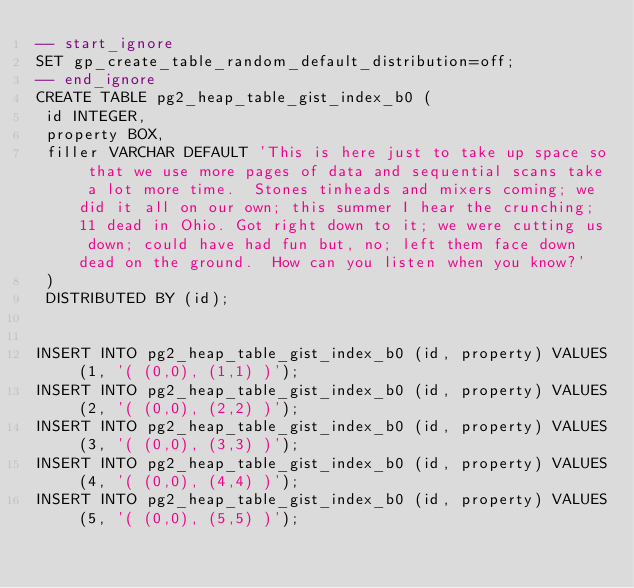<code> <loc_0><loc_0><loc_500><loc_500><_SQL_>-- start_ignore
SET gp_create_table_random_default_distribution=off;
-- end_ignore
CREATE TABLE pg2_heap_table_gist_index_b0 (
 id INTEGER,
 property BOX,
 filler VARCHAR DEFAULT 'This is here just to take up space so that we use more pages of data and sequential scans take a lot more time.  Stones tinheads and mixers coming; we did it all on our own; this summer I hear the crunching; 11 dead in Ohio. Got right down to it; we were cutting us down; could have had fun but, no; left them face down dead on the ground.  How can you listen when you know?'
 )
 DISTRIBUTED BY (id);


INSERT INTO pg2_heap_table_gist_index_b0 (id, property) VALUES (1, '( (0,0), (1,1) )');
INSERT INTO pg2_heap_table_gist_index_b0 (id, property) VALUES (2, '( (0,0), (2,2) )');
INSERT INTO pg2_heap_table_gist_index_b0 (id, property) VALUES (3, '( (0,0), (3,3) )');
INSERT INTO pg2_heap_table_gist_index_b0 (id, property) VALUES (4, '( (0,0), (4,4) )');
INSERT INTO pg2_heap_table_gist_index_b0 (id, property) VALUES (5, '( (0,0), (5,5) )');
</code> 